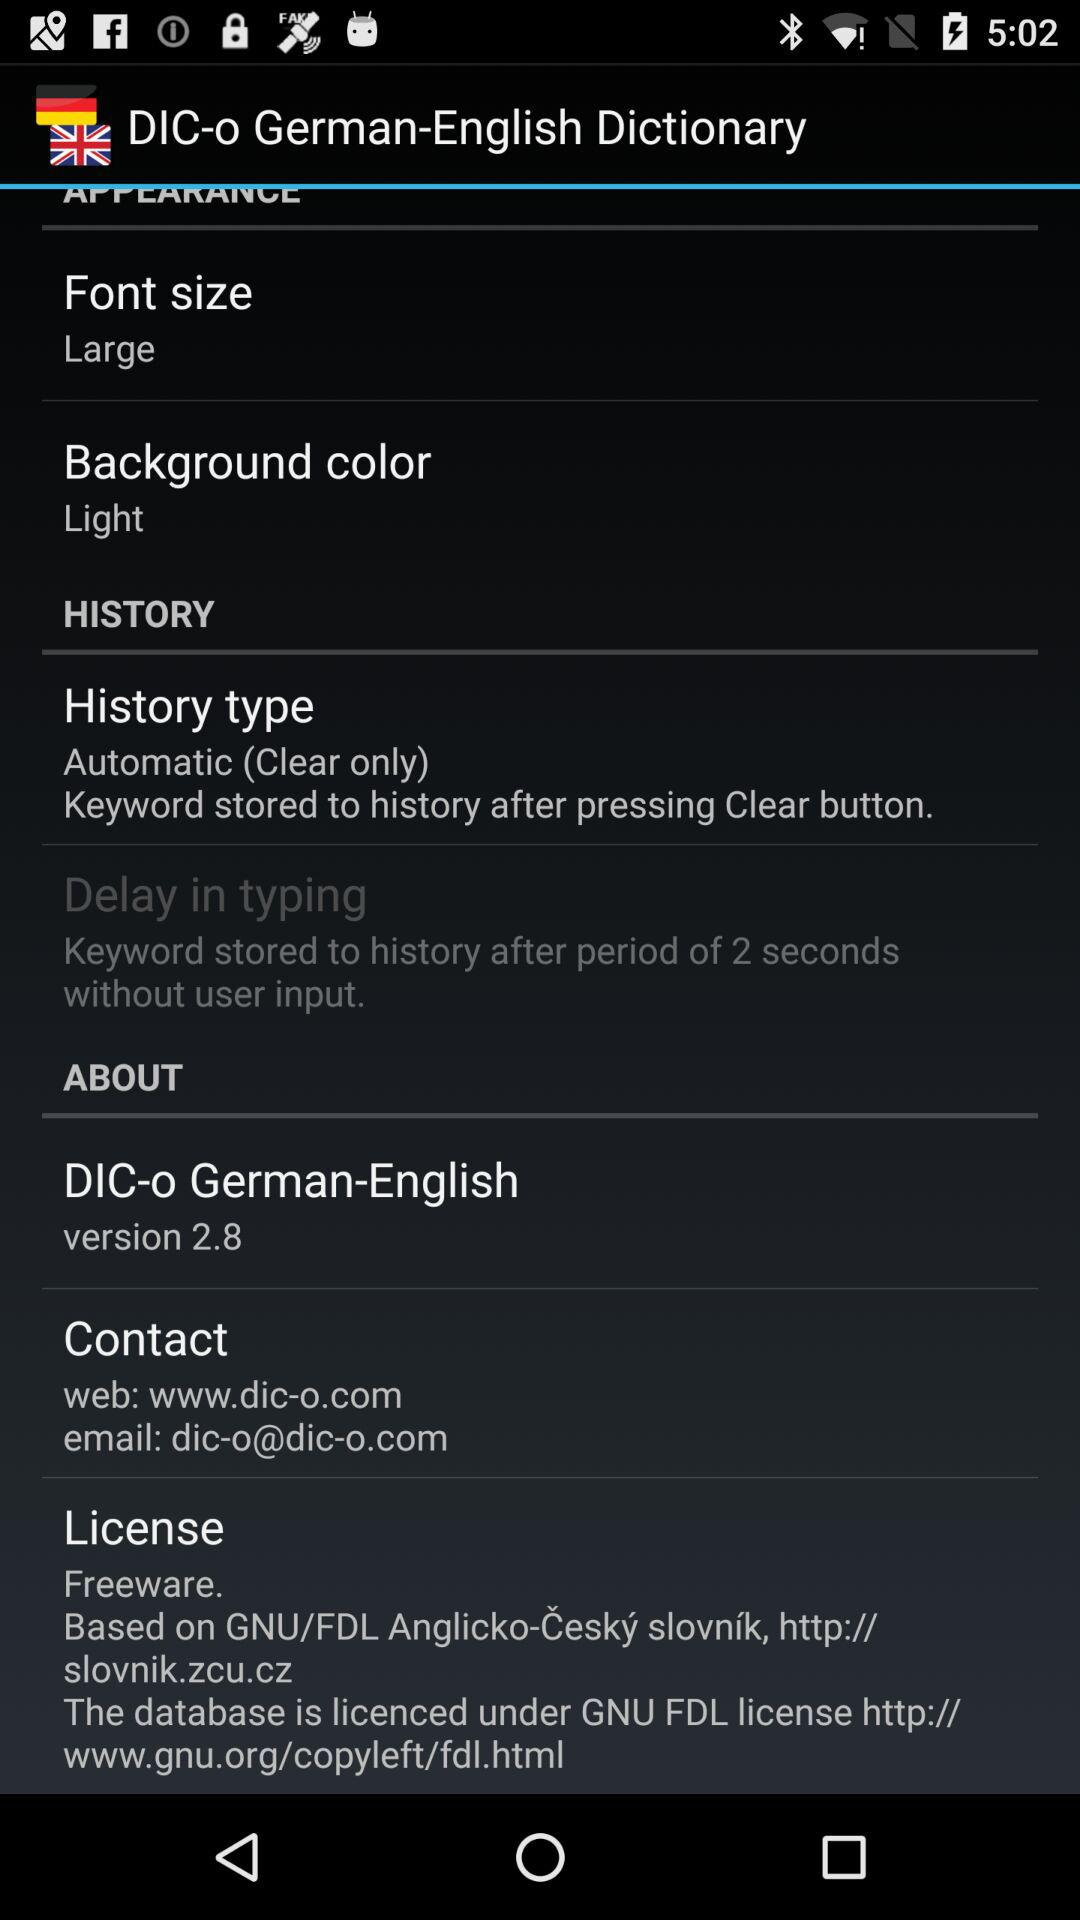What is the name of the application? The name of the application "DIC-o German-English Dictionary". 